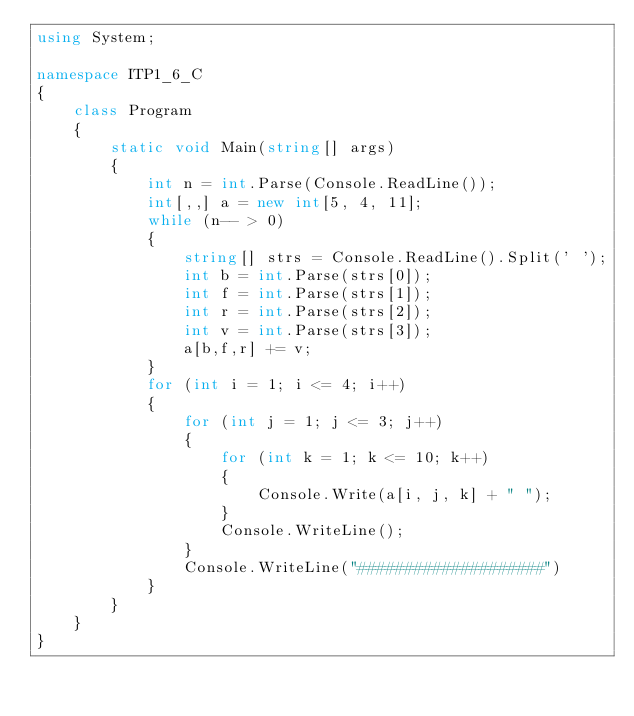<code> <loc_0><loc_0><loc_500><loc_500><_C#_>using System;

namespace ITP1_6_C
{
    class Program
    {
        static void Main(string[] args)
        {
            int n = int.Parse(Console.ReadLine());
            int[,,] a = new int[5, 4, 11];
            while (n-- > 0)
            {
                string[] strs = Console.ReadLine().Split(' ');
                int b = int.Parse(strs[0]);
                int f = int.Parse(strs[1]);
                int r = int.Parse(strs[2]);
                int v = int.Parse(strs[3]);
                a[b,f,r] += v;
            }
            for (int i = 1; i <= 4; i++)
            {
                for (int j = 1; j <= 3; j++)
                {
                    for (int k = 1; k <= 10; k++)
                    {
                        Console.Write(a[i, j, k] + " ");
                    }
                    Console.WriteLine();
                }
                Console.WriteLine("####################")
            }
        }
    }
}</code> 